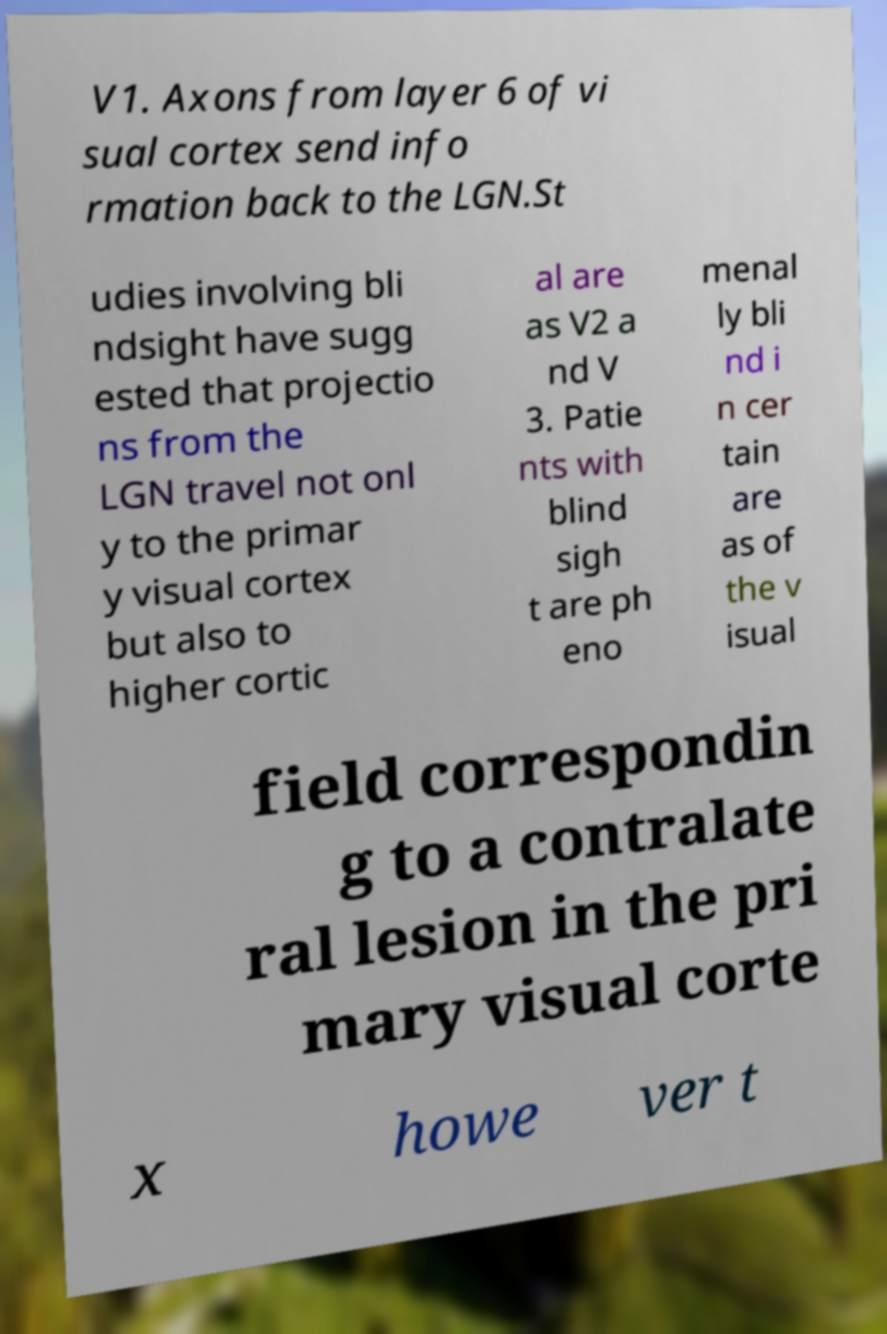Please read and relay the text visible in this image. What does it say? V1. Axons from layer 6 of vi sual cortex send info rmation back to the LGN.St udies involving bli ndsight have sugg ested that projectio ns from the LGN travel not onl y to the primar y visual cortex but also to higher cortic al are as V2 a nd V 3. Patie nts with blind sigh t are ph eno menal ly bli nd i n cer tain are as of the v isual field correspondin g to a contralate ral lesion in the pri mary visual corte x howe ver t 